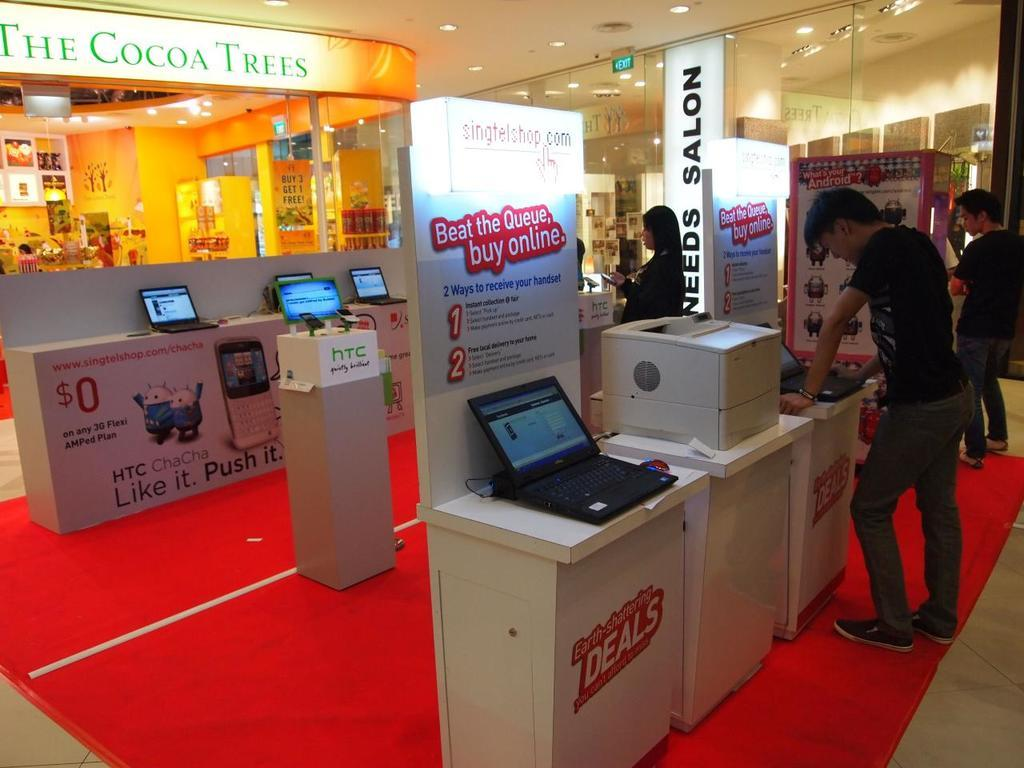Who or what can be seen in the image? There are people in the image. What electronic devices are visible in the image? There are laptops and mobiles in the image. What type of signage is present in the image? There are hoardings in the image. What can be seen in the background of the image? There are lights in the background of the image. What is written or displayed on the hoardings? There is text on the hoardings. Can you see an owl playing chess with a wave in the image? No, there is no owl, chess, or wave present in the image. 